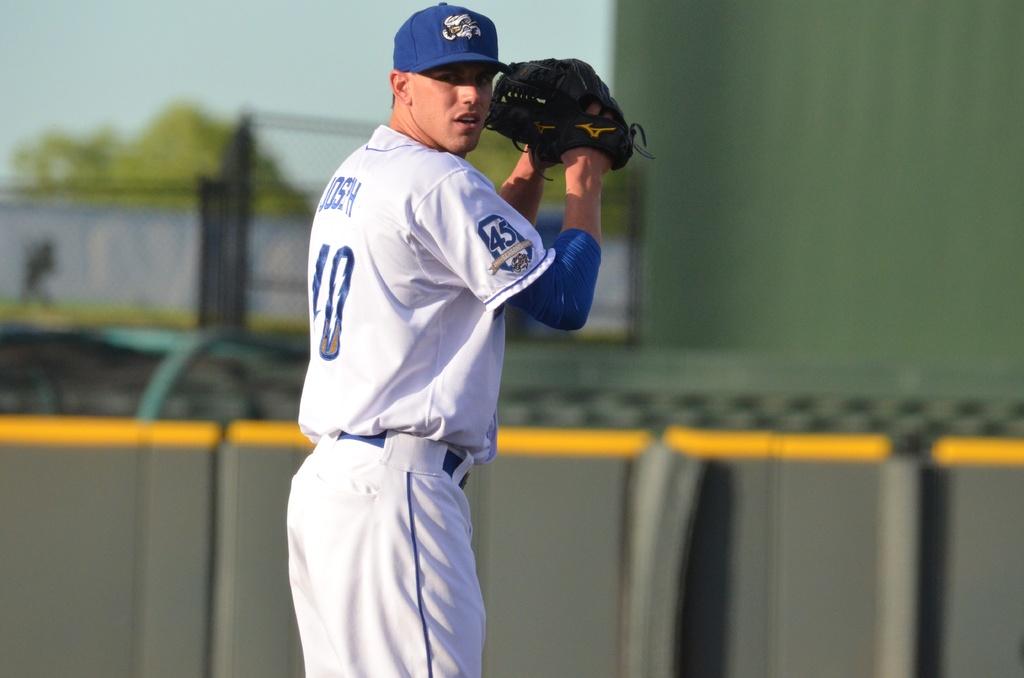What number is on the player's shoulder?
Your answer should be compact. 45. Does this players name start with "j"?
Your answer should be compact. Yes. 